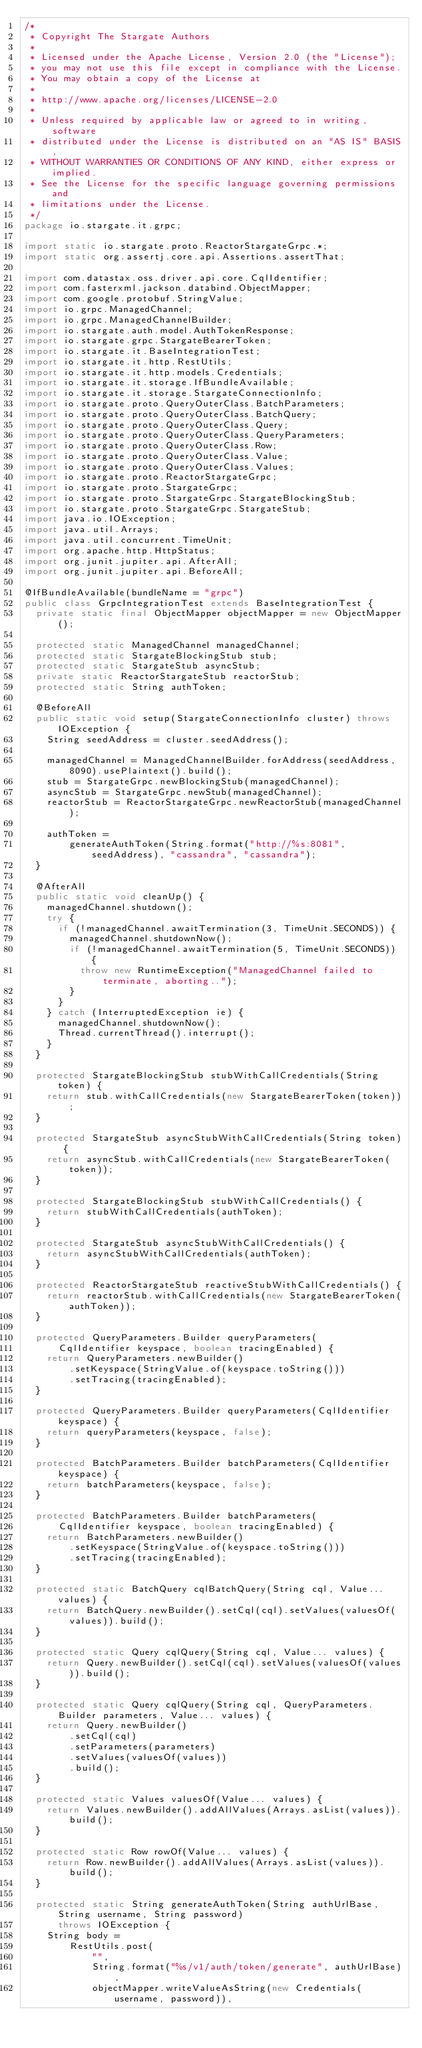Convert code to text. <code><loc_0><loc_0><loc_500><loc_500><_Java_>/*
 * Copyright The Stargate Authors
 *
 * Licensed under the Apache License, Version 2.0 (the "License");
 * you may not use this file except in compliance with the License.
 * You may obtain a copy of the License at
 *
 * http://www.apache.org/licenses/LICENSE-2.0
 *
 * Unless required by applicable law or agreed to in writing, software
 * distributed under the License is distributed on an "AS IS" BASIS,
 * WITHOUT WARRANTIES OR CONDITIONS OF ANY KIND, either express or implied.
 * See the License for the specific language governing permissions and
 * limitations under the License.
 */
package io.stargate.it.grpc;

import static io.stargate.proto.ReactorStargateGrpc.*;
import static org.assertj.core.api.Assertions.assertThat;

import com.datastax.oss.driver.api.core.CqlIdentifier;
import com.fasterxml.jackson.databind.ObjectMapper;
import com.google.protobuf.StringValue;
import io.grpc.ManagedChannel;
import io.grpc.ManagedChannelBuilder;
import io.stargate.auth.model.AuthTokenResponse;
import io.stargate.grpc.StargateBearerToken;
import io.stargate.it.BaseIntegrationTest;
import io.stargate.it.http.RestUtils;
import io.stargate.it.http.models.Credentials;
import io.stargate.it.storage.IfBundleAvailable;
import io.stargate.it.storage.StargateConnectionInfo;
import io.stargate.proto.QueryOuterClass.BatchParameters;
import io.stargate.proto.QueryOuterClass.BatchQuery;
import io.stargate.proto.QueryOuterClass.Query;
import io.stargate.proto.QueryOuterClass.QueryParameters;
import io.stargate.proto.QueryOuterClass.Row;
import io.stargate.proto.QueryOuterClass.Value;
import io.stargate.proto.QueryOuterClass.Values;
import io.stargate.proto.ReactorStargateGrpc;
import io.stargate.proto.StargateGrpc;
import io.stargate.proto.StargateGrpc.StargateBlockingStub;
import io.stargate.proto.StargateGrpc.StargateStub;
import java.io.IOException;
import java.util.Arrays;
import java.util.concurrent.TimeUnit;
import org.apache.http.HttpStatus;
import org.junit.jupiter.api.AfterAll;
import org.junit.jupiter.api.BeforeAll;

@IfBundleAvailable(bundleName = "grpc")
public class GrpcIntegrationTest extends BaseIntegrationTest {
  private static final ObjectMapper objectMapper = new ObjectMapper();

  protected static ManagedChannel managedChannel;
  protected static StargateBlockingStub stub;
  protected static StargateStub asyncStub;
  private static ReactorStargateStub reactorStub;
  protected static String authToken;

  @BeforeAll
  public static void setup(StargateConnectionInfo cluster) throws IOException {
    String seedAddress = cluster.seedAddress();

    managedChannel = ManagedChannelBuilder.forAddress(seedAddress, 8090).usePlaintext().build();
    stub = StargateGrpc.newBlockingStub(managedChannel);
    asyncStub = StargateGrpc.newStub(managedChannel);
    reactorStub = ReactorStargateGrpc.newReactorStub(managedChannel);

    authToken =
        generateAuthToken(String.format("http://%s:8081", seedAddress), "cassandra", "cassandra");
  }

  @AfterAll
  public static void cleanUp() {
    managedChannel.shutdown();
    try {
      if (!managedChannel.awaitTermination(3, TimeUnit.SECONDS)) {
        managedChannel.shutdownNow();
        if (!managedChannel.awaitTermination(5, TimeUnit.SECONDS)) {
          throw new RuntimeException("ManagedChannel failed to terminate, aborting..");
        }
      }
    } catch (InterruptedException ie) {
      managedChannel.shutdownNow();
      Thread.currentThread().interrupt();
    }
  }

  protected StargateBlockingStub stubWithCallCredentials(String token) {
    return stub.withCallCredentials(new StargateBearerToken(token));
  }

  protected StargateStub asyncStubWithCallCredentials(String token) {
    return asyncStub.withCallCredentials(new StargateBearerToken(token));
  }

  protected StargateBlockingStub stubWithCallCredentials() {
    return stubWithCallCredentials(authToken);
  }

  protected StargateStub asyncStubWithCallCredentials() {
    return asyncStubWithCallCredentials(authToken);
  }

  protected ReactorStargateStub reactiveStubWithCallCredentials() {
    return reactorStub.withCallCredentials(new StargateBearerToken(authToken));
  }

  protected QueryParameters.Builder queryParameters(
      CqlIdentifier keyspace, boolean tracingEnabled) {
    return QueryParameters.newBuilder()
        .setKeyspace(StringValue.of(keyspace.toString()))
        .setTracing(tracingEnabled);
  }

  protected QueryParameters.Builder queryParameters(CqlIdentifier keyspace) {
    return queryParameters(keyspace, false);
  }

  protected BatchParameters.Builder batchParameters(CqlIdentifier keyspace) {
    return batchParameters(keyspace, false);
  }

  protected BatchParameters.Builder batchParameters(
      CqlIdentifier keyspace, boolean tracingEnabled) {
    return BatchParameters.newBuilder()
        .setKeyspace(StringValue.of(keyspace.toString()))
        .setTracing(tracingEnabled);
  }

  protected static BatchQuery cqlBatchQuery(String cql, Value... values) {
    return BatchQuery.newBuilder().setCql(cql).setValues(valuesOf(values)).build();
  }

  protected static Query cqlQuery(String cql, Value... values) {
    return Query.newBuilder().setCql(cql).setValues(valuesOf(values)).build();
  }

  protected static Query cqlQuery(String cql, QueryParameters.Builder parameters, Value... values) {
    return Query.newBuilder()
        .setCql(cql)
        .setParameters(parameters)
        .setValues(valuesOf(values))
        .build();
  }

  protected static Values valuesOf(Value... values) {
    return Values.newBuilder().addAllValues(Arrays.asList(values)).build();
  }

  protected static Row rowOf(Value... values) {
    return Row.newBuilder().addAllValues(Arrays.asList(values)).build();
  }

  protected static String generateAuthToken(String authUrlBase, String username, String password)
      throws IOException {
    String body =
        RestUtils.post(
            "",
            String.format("%s/v1/auth/token/generate", authUrlBase),
            objectMapper.writeValueAsString(new Credentials(username, password)),</code> 